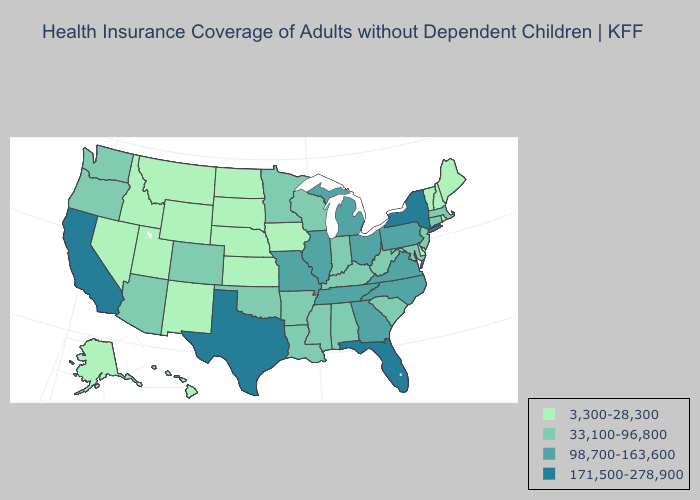Is the legend a continuous bar?
Write a very short answer. No. Name the states that have a value in the range 3,300-28,300?
Concise answer only. Alaska, Delaware, Hawaii, Idaho, Iowa, Kansas, Maine, Montana, Nebraska, Nevada, New Hampshire, New Mexico, North Dakota, Rhode Island, South Dakota, Utah, Vermont, Wyoming. Name the states that have a value in the range 171,500-278,900?
Give a very brief answer. California, Florida, New York, Texas. What is the lowest value in the Northeast?
Keep it brief. 3,300-28,300. Does Delaware have the lowest value in the South?
Give a very brief answer. Yes. Name the states that have a value in the range 33,100-96,800?
Be succinct. Alabama, Arizona, Arkansas, Colorado, Connecticut, Indiana, Kentucky, Louisiana, Maryland, Massachusetts, Minnesota, Mississippi, New Jersey, Oklahoma, Oregon, South Carolina, Washington, West Virginia, Wisconsin. Among the states that border Georgia , which have the lowest value?
Give a very brief answer. Alabama, South Carolina. How many symbols are there in the legend?
Keep it brief. 4. What is the highest value in the Northeast ?
Write a very short answer. 171,500-278,900. How many symbols are there in the legend?
Give a very brief answer. 4. What is the value of Alaska?
Write a very short answer. 3,300-28,300. Does Indiana have the lowest value in the USA?
Give a very brief answer. No. What is the highest value in the MidWest ?
Be succinct. 98,700-163,600. Name the states that have a value in the range 3,300-28,300?
Quick response, please. Alaska, Delaware, Hawaii, Idaho, Iowa, Kansas, Maine, Montana, Nebraska, Nevada, New Hampshire, New Mexico, North Dakota, Rhode Island, South Dakota, Utah, Vermont, Wyoming. Among the states that border Connecticut , does Rhode Island have the lowest value?
Be succinct. Yes. 